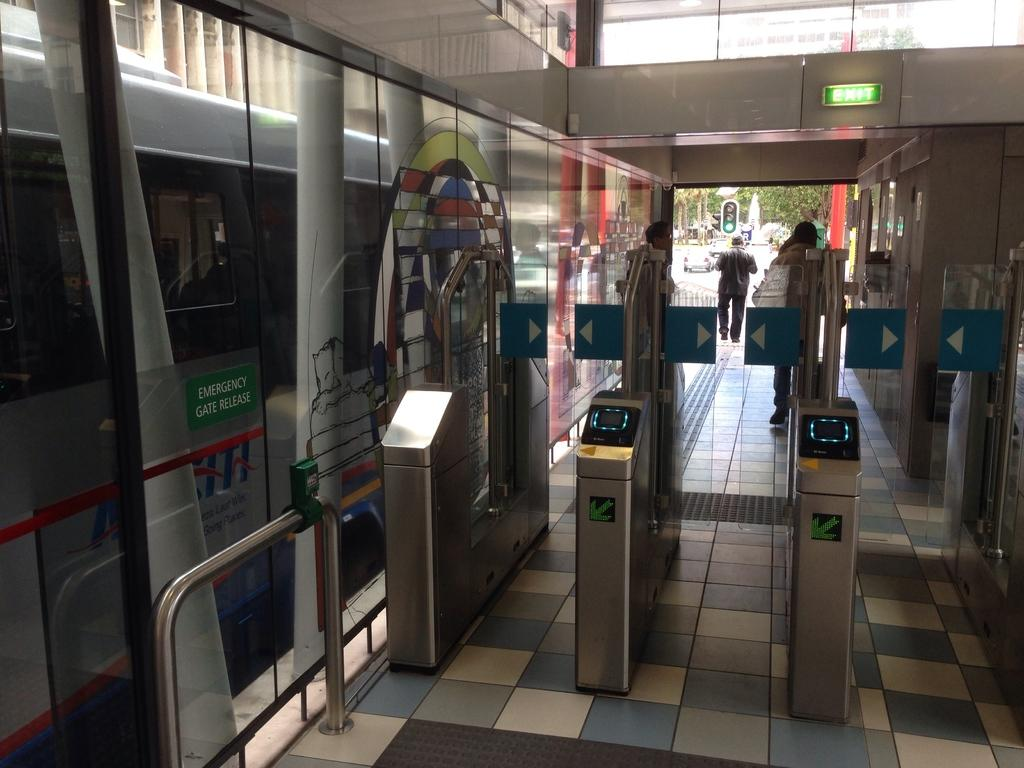<image>
Share a concise interpretation of the image provided. The silver bus has a green sign labeled Emergency Gate Release. 